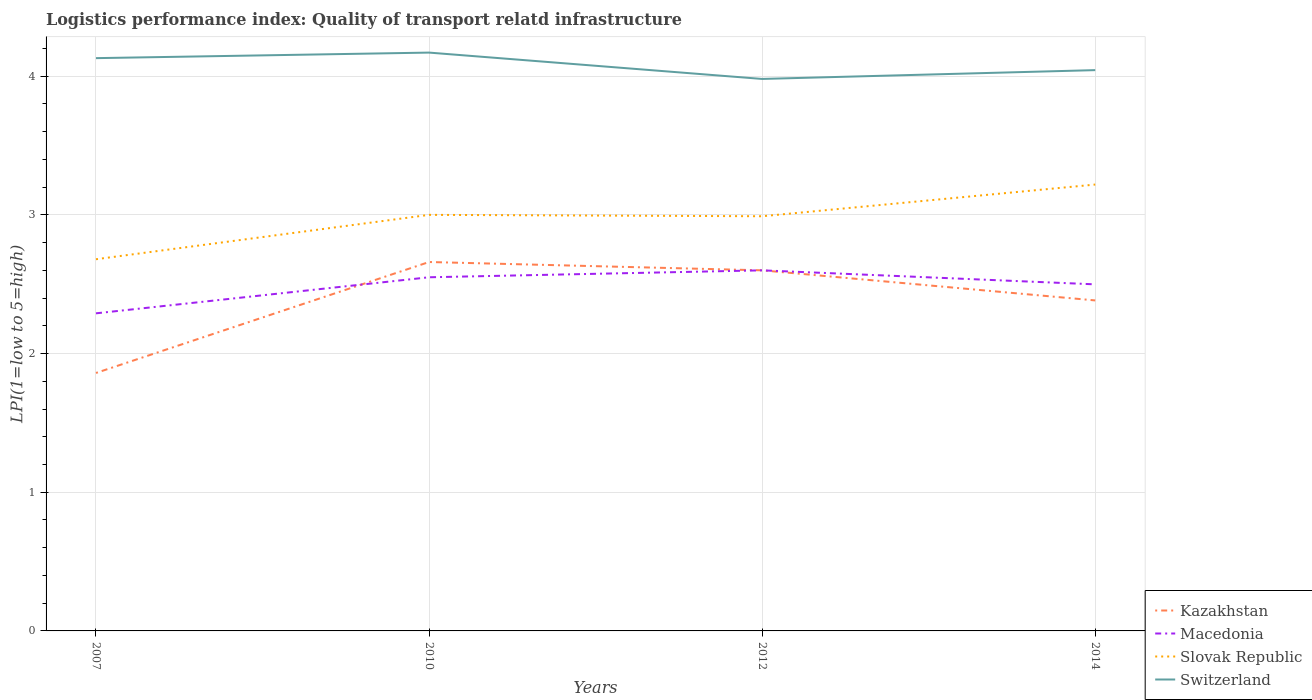How many different coloured lines are there?
Offer a terse response. 4. Does the line corresponding to Kazakhstan intersect with the line corresponding to Slovak Republic?
Your answer should be compact. No. Is the number of lines equal to the number of legend labels?
Offer a very short reply. Yes. Across all years, what is the maximum logistics performance index in Slovak Republic?
Your response must be concise. 2.68. In which year was the logistics performance index in Kazakhstan maximum?
Offer a very short reply. 2007. What is the total logistics performance index in Switzerland in the graph?
Make the answer very short. 0.15. What is the difference between the highest and the second highest logistics performance index in Switzerland?
Offer a terse response. 0.19. Is the logistics performance index in Switzerland strictly greater than the logistics performance index in Kazakhstan over the years?
Ensure brevity in your answer.  No. How many lines are there?
Make the answer very short. 4. How many years are there in the graph?
Offer a terse response. 4. What is the difference between two consecutive major ticks on the Y-axis?
Your answer should be very brief. 1. Are the values on the major ticks of Y-axis written in scientific E-notation?
Offer a terse response. No. Does the graph contain any zero values?
Your answer should be compact. No. Does the graph contain grids?
Make the answer very short. Yes. Where does the legend appear in the graph?
Give a very brief answer. Bottom right. What is the title of the graph?
Offer a terse response. Logistics performance index: Quality of transport relatd infrastructure. What is the label or title of the X-axis?
Provide a succinct answer. Years. What is the label or title of the Y-axis?
Offer a terse response. LPI(1=low to 5=high). What is the LPI(1=low to 5=high) in Kazakhstan in 2007?
Your answer should be compact. 1.86. What is the LPI(1=low to 5=high) in Macedonia in 2007?
Your answer should be compact. 2.29. What is the LPI(1=low to 5=high) in Slovak Republic in 2007?
Give a very brief answer. 2.68. What is the LPI(1=low to 5=high) in Switzerland in 2007?
Provide a short and direct response. 4.13. What is the LPI(1=low to 5=high) in Kazakhstan in 2010?
Ensure brevity in your answer.  2.66. What is the LPI(1=low to 5=high) in Macedonia in 2010?
Your answer should be compact. 2.55. What is the LPI(1=low to 5=high) of Slovak Republic in 2010?
Provide a short and direct response. 3. What is the LPI(1=low to 5=high) in Switzerland in 2010?
Your answer should be compact. 4.17. What is the LPI(1=low to 5=high) of Slovak Republic in 2012?
Keep it short and to the point. 2.99. What is the LPI(1=low to 5=high) in Switzerland in 2012?
Give a very brief answer. 3.98. What is the LPI(1=low to 5=high) in Kazakhstan in 2014?
Your answer should be compact. 2.38. What is the LPI(1=low to 5=high) of Macedonia in 2014?
Offer a terse response. 2.5. What is the LPI(1=low to 5=high) in Slovak Republic in 2014?
Give a very brief answer. 3.22. What is the LPI(1=low to 5=high) of Switzerland in 2014?
Ensure brevity in your answer.  4.04. Across all years, what is the maximum LPI(1=low to 5=high) in Kazakhstan?
Ensure brevity in your answer.  2.66. Across all years, what is the maximum LPI(1=low to 5=high) in Macedonia?
Give a very brief answer. 2.6. Across all years, what is the maximum LPI(1=low to 5=high) of Slovak Republic?
Provide a short and direct response. 3.22. Across all years, what is the maximum LPI(1=low to 5=high) in Switzerland?
Give a very brief answer. 4.17. Across all years, what is the minimum LPI(1=low to 5=high) in Kazakhstan?
Make the answer very short. 1.86. Across all years, what is the minimum LPI(1=low to 5=high) in Macedonia?
Provide a short and direct response. 2.29. Across all years, what is the minimum LPI(1=low to 5=high) of Slovak Republic?
Provide a short and direct response. 2.68. Across all years, what is the minimum LPI(1=low to 5=high) of Switzerland?
Your response must be concise. 3.98. What is the total LPI(1=low to 5=high) of Kazakhstan in the graph?
Offer a very short reply. 9.5. What is the total LPI(1=low to 5=high) in Macedonia in the graph?
Your response must be concise. 9.94. What is the total LPI(1=low to 5=high) of Slovak Republic in the graph?
Keep it short and to the point. 11.89. What is the total LPI(1=low to 5=high) in Switzerland in the graph?
Ensure brevity in your answer.  16.32. What is the difference between the LPI(1=low to 5=high) of Macedonia in 2007 and that in 2010?
Keep it short and to the point. -0.26. What is the difference between the LPI(1=low to 5=high) in Slovak Republic in 2007 and that in 2010?
Your answer should be very brief. -0.32. What is the difference between the LPI(1=low to 5=high) in Switzerland in 2007 and that in 2010?
Your response must be concise. -0.04. What is the difference between the LPI(1=low to 5=high) of Kazakhstan in 2007 and that in 2012?
Keep it short and to the point. -0.74. What is the difference between the LPI(1=low to 5=high) of Macedonia in 2007 and that in 2012?
Give a very brief answer. -0.31. What is the difference between the LPI(1=low to 5=high) of Slovak Republic in 2007 and that in 2012?
Provide a succinct answer. -0.31. What is the difference between the LPI(1=low to 5=high) in Switzerland in 2007 and that in 2012?
Provide a succinct answer. 0.15. What is the difference between the LPI(1=low to 5=high) of Kazakhstan in 2007 and that in 2014?
Keep it short and to the point. -0.52. What is the difference between the LPI(1=low to 5=high) of Macedonia in 2007 and that in 2014?
Your response must be concise. -0.21. What is the difference between the LPI(1=low to 5=high) of Slovak Republic in 2007 and that in 2014?
Your response must be concise. -0.54. What is the difference between the LPI(1=low to 5=high) of Switzerland in 2007 and that in 2014?
Offer a very short reply. 0.09. What is the difference between the LPI(1=low to 5=high) of Kazakhstan in 2010 and that in 2012?
Offer a terse response. 0.06. What is the difference between the LPI(1=low to 5=high) in Macedonia in 2010 and that in 2012?
Make the answer very short. -0.05. What is the difference between the LPI(1=low to 5=high) in Slovak Republic in 2010 and that in 2012?
Offer a terse response. 0.01. What is the difference between the LPI(1=low to 5=high) of Switzerland in 2010 and that in 2012?
Make the answer very short. 0.19. What is the difference between the LPI(1=low to 5=high) of Kazakhstan in 2010 and that in 2014?
Provide a succinct answer. 0.28. What is the difference between the LPI(1=low to 5=high) in Macedonia in 2010 and that in 2014?
Your answer should be compact. 0.05. What is the difference between the LPI(1=low to 5=high) in Slovak Republic in 2010 and that in 2014?
Provide a succinct answer. -0.22. What is the difference between the LPI(1=low to 5=high) in Switzerland in 2010 and that in 2014?
Keep it short and to the point. 0.13. What is the difference between the LPI(1=low to 5=high) in Kazakhstan in 2012 and that in 2014?
Offer a very short reply. 0.22. What is the difference between the LPI(1=low to 5=high) in Macedonia in 2012 and that in 2014?
Keep it short and to the point. 0.1. What is the difference between the LPI(1=low to 5=high) of Slovak Republic in 2012 and that in 2014?
Your answer should be very brief. -0.23. What is the difference between the LPI(1=low to 5=high) in Switzerland in 2012 and that in 2014?
Provide a succinct answer. -0.06. What is the difference between the LPI(1=low to 5=high) in Kazakhstan in 2007 and the LPI(1=low to 5=high) in Macedonia in 2010?
Your answer should be compact. -0.69. What is the difference between the LPI(1=low to 5=high) in Kazakhstan in 2007 and the LPI(1=low to 5=high) in Slovak Republic in 2010?
Your answer should be compact. -1.14. What is the difference between the LPI(1=low to 5=high) in Kazakhstan in 2007 and the LPI(1=low to 5=high) in Switzerland in 2010?
Give a very brief answer. -2.31. What is the difference between the LPI(1=low to 5=high) of Macedonia in 2007 and the LPI(1=low to 5=high) of Slovak Republic in 2010?
Ensure brevity in your answer.  -0.71. What is the difference between the LPI(1=low to 5=high) of Macedonia in 2007 and the LPI(1=low to 5=high) of Switzerland in 2010?
Your response must be concise. -1.88. What is the difference between the LPI(1=low to 5=high) of Slovak Republic in 2007 and the LPI(1=low to 5=high) of Switzerland in 2010?
Offer a terse response. -1.49. What is the difference between the LPI(1=low to 5=high) of Kazakhstan in 2007 and the LPI(1=low to 5=high) of Macedonia in 2012?
Provide a succinct answer. -0.74. What is the difference between the LPI(1=low to 5=high) in Kazakhstan in 2007 and the LPI(1=low to 5=high) in Slovak Republic in 2012?
Your answer should be compact. -1.13. What is the difference between the LPI(1=low to 5=high) in Kazakhstan in 2007 and the LPI(1=low to 5=high) in Switzerland in 2012?
Give a very brief answer. -2.12. What is the difference between the LPI(1=low to 5=high) in Macedonia in 2007 and the LPI(1=low to 5=high) in Switzerland in 2012?
Keep it short and to the point. -1.69. What is the difference between the LPI(1=low to 5=high) in Slovak Republic in 2007 and the LPI(1=low to 5=high) in Switzerland in 2012?
Ensure brevity in your answer.  -1.3. What is the difference between the LPI(1=low to 5=high) in Kazakhstan in 2007 and the LPI(1=low to 5=high) in Macedonia in 2014?
Offer a very short reply. -0.64. What is the difference between the LPI(1=low to 5=high) in Kazakhstan in 2007 and the LPI(1=low to 5=high) in Slovak Republic in 2014?
Keep it short and to the point. -1.36. What is the difference between the LPI(1=low to 5=high) of Kazakhstan in 2007 and the LPI(1=low to 5=high) of Switzerland in 2014?
Give a very brief answer. -2.18. What is the difference between the LPI(1=low to 5=high) in Macedonia in 2007 and the LPI(1=low to 5=high) in Slovak Republic in 2014?
Your answer should be compact. -0.93. What is the difference between the LPI(1=low to 5=high) in Macedonia in 2007 and the LPI(1=low to 5=high) in Switzerland in 2014?
Make the answer very short. -1.75. What is the difference between the LPI(1=low to 5=high) in Slovak Republic in 2007 and the LPI(1=low to 5=high) in Switzerland in 2014?
Offer a very short reply. -1.36. What is the difference between the LPI(1=low to 5=high) in Kazakhstan in 2010 and the LPI(1=low to 5=high) in Macedonia in 2012?
Your answer should be compact. 0.06. What is the difference between the LPI(1=low to 5=high) in Kazakhstan in 2010 and the LPI(1=low to 5=high) in Slovak Republic in 2012?
Provide a short and direct response. -0.33. What is the difference between the LPI(1=low to 5=high) of Kazakhstan in 2010 and the LPI(1=low to 5=high) of Switzerland in 2012?
Offer a terse response. -1.32. What is the difference between the LPI(1=low to 5=high) of Macedonia in 2010 and the LPI(1=low to 5=high) of Slovak Republic in 2012?
Give a very brief answer. -0.44. What is the difference between the LPI(1=low to 5=high) of Macedonia in 2010 and the LPI(1=low to 5=high) of Switzerland in 2012?
Your answer should be very brief. -1.43. What is the difference between the LPI(1=low to 5=high) of Slovak Republic in 2010 and the LPI(1=low to 5=high) of Switzerland in 2012?
Make the answer very short. -0.98. What is the difference between the LPI(1=low to 5=high) of Kazakhstan in 2010 and the LPI(1=low to 5=high) of Macedonia in 2014?
Provide a succinct answer. 0.16. What is the difference between the LPI(1=low to 5=high) in Kazakhstan in 2010 and the LPI(1=low to 5=high) in Slovak Republic in 2014?
Provide a succinct answer. -0.56. What is the difference between the LPI(1=low to 5=high) of Kazakhstan in 2010 and the LPI(1=low to 5=high) of Switzerland in 2014?
Your response must be concise. -1.38. What is the difference between the LPI(1=low to 5=high) of Macedonia in 2010 and the LPI(1=low to 5=high) of Slovak Republic in 2014?
Your answer should be compact. -0.67. What is the difference between the LPI(1=low to 5=high) in Macedonia in 2010 and the LPI(1=low to 5=high) in Switzerland in 2014?
Your answer should be very brief. -1.49. What is the difference between the LPI(1=low to 5=high) of Slovak Republic in 2010 and the LPI(1=low to 5=high) of Switzerland in 2014?
Offer a very short reply. -1.04. What is the difference between the LPI(1=low to 5=high) of Kazakhstan in 2012 and the LPI(1=low to 5=high) of Macedonia in 2014?
Your answer should be compact. 0.1. What is the difference between the LPI(1=low to 5=high) of Kazakhstan in 2012 and the LPI(1=low to 5=high) of Slovak Republic in 2014?
Your response must be concise. -0.62. What is the difference between the LPI(1=low to 5=high) in Kazakhstan in 2012 and the LPI(1=low to 5=high) in Switzerland in 2014?
Provide a short and direct response. -1.44. What is the difference between the LPI(1=low to 5=high) of Macedonia in 2012 and the LPI(1=low to 5=high) of Slovak Republic in 2014?
Keep it short and to the point. -0.62. What is the difference between the LPI(1=low to 5=high) of Macedonia in 2012 and the LPI(1=low to 5=high) of Switzerland in 2014?
Give a very brief answer. -1.44. What is the difference between the LPI(1=low to 5=high) of Slovak Republic in 2012 and the LPI(1=low to 5=high) of Switzerland in 2014?
Your answer should be compact. -1.05. What is the average LPI(1=low to 5=high) of Kazakhstan per year?
Your answer should be compact. 2.38. What is the average LPI(1=low to 5=high) in Macedonia per year?
Ensure brevity in your answer.  2.48. What is the average LPI(1=low to 5=high) of Slovak Republic per year?
Offer a terse response. 2.97. What is the average LPI(1=low to 5=high) of Switzerland per year?
Your answer should be very brief. 4.08. In the year 2007, what is the difference between the LPI(1=low to 5=high) in Kazakhstan and LPI(1=low to 5=high) in Macedonia?
Offer a terse response. -0.43. In the year 2007, what is the difference between the LPI(1=low to 5=high) of Kazakhstan and LPI(1=low to 5=high) of Slovak Republic?
Offer a terse response. -0.82. In the year 2007, what is the difference between the LPI(1=low to 5=high) of Kazakhstan and LPI(1=low to 5=high) of Switzerland?
Your response must be concise. -2.27. In the year 2007, what is the difference between the LPI(1=low to 5=high) of Macedonia and LPI(1=low to 5=high) of Slovak Republic?
Ensure brevity in your answer.  -0.39. In the year 2007, what is the difference between the LPI(1=low to 5=high) of Macedonia and LPI(1=low to 5=high) of Switzerland?
Offer a very short reply. -1.84. In the year 2007, what is the difference between the LPI(1=low to 5=high) in Slovak Republic and LPI(1=low to 5=high) in Switzerland?
Provide a short and direct response. -1.45. In the year 2010, what is the difference between the LPI(1=low to 5=high) in Kazakhstan and LPI(1=low to 5=high) in Macedonia?
Provide a succinct answer. 0.11. In the year 2010, what is the difference between the LPI(1=low to 5=high) of Kazakhstan and LPI(1=low to 5=high) of Slovak Republic?
Keep it short and to the point. -0.34. In the year 2010, what is the difference between the LPI(1=low to 5=high) in Kazakhstan and LPI(1=low to 5=high) in Switzerland?
Offer a terse response. -1.51. In the year 2010, what is the difference between the LPI(1=low to 5=high) in Macedonia and LPI(1=low to 5=high) in Slovak Republic?
Ensure brevity in your answer.  -0.45. In the year 2010, what is the difference between the LPI(1=low to 5=high) in Macedonia and LPI(1=low to 5=high) in Switzerland?
Your answer should be compact. -1.62. In the year 2010, what is the difference between the LPI(1=low to 5=high) of Slovak Republic and LPI(1=low to 5=high) of Switzerland?
Keep it short and to the point. -1.17. In the year 2012, what is the difference between the LPI(1=low to 5=high) of Kazakhstan and LPI(1=low to 5=high) of Macedonia?
Ensure brevity in your answer.  0. In the year 2012, what is the difference between the LPI(1=low to 5=high) in Kazakhstan and LPI(1=low to 5=high) in Slovak Republic?
Your answer should be compact. -0.39. In the year 2012, what is the difference between the LPI(1=low to 5=high) in Kazakhstan and LPI(1=low to 5=high) in Switzerland?
Keep it short and to the point. -1.38. In the year 2012, what is the difference between the LPI(1=low to 5=high) of Macedonia and LPI(1=low to 5=high) of Slovak Republic?
Your answer should be very brief. -0.39. In the year 2012, what is the difference between the LPI(1=low to 5=high) in Macedonia and LPI(1=low to 5=high) in Switzerland?
Provide a succinct answer. -1.38. In the year 2012, what is the difference between the LPI(1=low to 5=high) in Slovak Republic and LPI(1=low to 5=high) in Switzerland?
Ensure brevity in your answer.  -0.99. In the year 2014, what is the difference between the LPI(1=low to 5=high) of Kazakhstan and LPI(1=low to 5=high) of Macedonia?
Ensure brevity in your answer.  -0.12. In the year 2014, what is the difference between the LPI(1=low to 5=high) in Kazakhstan and LPI(1=low to 5=high) in Slovak Republic?
Make the answer very short. -0.84. In the year 2014, what is the difference between the LPI(1=low to 5=high) in Kazakhstan and LPI(1=low to 5=high) in Switzerland?
Keep it short and to the point. -1.66. In the year 2014, what is the difference between the LPI(1=low to 5=high) of Macedonia and LPI(1=low to 5=high) of Slovak Republic?
Make the answer very short. -0.72. In the year 2014, what is the difference between the LPI(1=low to 5=high) in Macedonia and LPI(1=low to 5=high) in Switzerland?
Offer a very short reply. -1.54. In the year 2014, what is the difference between the LPI(1=low to 5=high) of Slovak Republic and LPI(1=low to 5=high) of Switzerland?
Keep it short and to the point. -0.83. What is the ratio of the LPI(1=low to 5=high) in Kazakhstan in 2007 to that in 2010?
Your response must be concise. 0.7. What is the ratio of the LPI(1=low to 5=high) of Macedonia in 2007 to that in 2010?
Keep it short and to the point. 0.9. What is the ratio of the LPI(1=low to 5=high) in Slovak Republic in 2007 to that in 2010?
Your response must be concise. 0.89. What is the ratio of the LPI(1=low to 5=high) in Switzerland in 2007 to that in 2010?
Provide a succinct answer. 0.99. What is the ratio of the LPI(1=low to 5=high) in Kazakhstan in 2007 to that in 2012?
Give a very brief answer. 0.72. What is the ratio of the LPI(1=low to 5=high) of Macedonia in 2007 to that in 2012?
Give a very brief answer. 0.88. What is the ratio of the LPI(1=low to 5=high) of Slovak Republic in 2007 to that in 2012?
Your answer should be very brief. 0.9. What is the ratio of the LPI(1=low to 5=high) of Switzerland in 2007 to that in 2012?
Offer a terse response. 1.04. What is the ratio of the LPI(1=low to 5=high) in Kazakhstan in 2007 to that in 2014?
Provide a short and direct response. 0.78. What is the ratio of the LPI(1=low to 5=high) in Macedonia in 2007 to that in 2014?
Provide a succinct answer. 0.92. What is the ratio of the LPI(1=low to 5=high) in Slovak Republic in 2007 to that in 2014?
Ensure brevity in your answer.  0.83. What is the ratio of the LPI(1=low to 5=high) in Switzerland in 2007 to that in 2014?
Your answer should be compact. 1.02. What is the ratio of the LPI(1=low to 5=high) of Kazakhstan in 2010 to that in 2012?
Your response must be concise. 1.02. What is the ratio of the LPI(1=low to 5=high) in Macedonia in 2010 to that in 2012?
Your response must be concise. 0.98. What is the ratio of the LPI(1=low to 5=high) of Slovak Republic in 2010 to that in 2012?
Ensure brevity in your answer.  1. What is the ratio of the LPI(1=low to 5=high) in Switzerland in 2010 to that in 2012?
Provide a succinct answer. 1.05. What is the ratio of the LPI(1=low to 5=high) of Kazakhstan in 2010 to that in 2014?
Give a very brief answer. 1.12. What is the ratio of the LPI(1=low to 5=high) of Macedonia in 2010 to that in 2014?
Make the answer very short. 1.02. What is the ratio of the LPI(1=low to 5=high) of Slovak Republic in 2010 to that in 2014?
Provide a succinct answer. 0.93. What is the ratio of the LPI(1=low to 5=high) in Switzerland in 2010 to that in 2014?
Offer a very short reply. 1.03. What is the ratio of the LPI(1=low to 5=high) of Kazakhstan in 2012 to that in 2014?
Offer a terse response. 1.09. What is the ratio of the LPI(1=low to 5=high) in Macedonia in 2012 to that in 2014?
Your answer should be very brief. 1.04. What is the ratio of the LPI(1=low to 5=high) of Slovak Republic in 2012 to that in 2014?
Ensure brevity in your answer.  0.93. What is the ratio of the LPI(1=low to 5=high) of Switzerland in 2012 to that in 2014?
Provide a short and direct response. 0.98. What is the difference between the highest and the second highest LPI(1=low to 5=high) of Slovak Republic?
Give a very brief answer. 0.22. What is the difference between the highest and the lowest LPI(1=low to 5=high) in Kazakhstan?
Offer a very short reply. 0.8. What is the difference between the highest and the lowest LPI(1=low to 5=high) of Macedonia?
Offer a terse response. 0.31. What is the difference between the highest and the lowest LPI(1=low to 5=high) in Slovak Republic?
Ensure brevity in your answer.  0.54. What is the difference between the highest and the lowest LPI(1=low to 5=high) of Switzerland?
Your answer should be very brief. 0.19. 